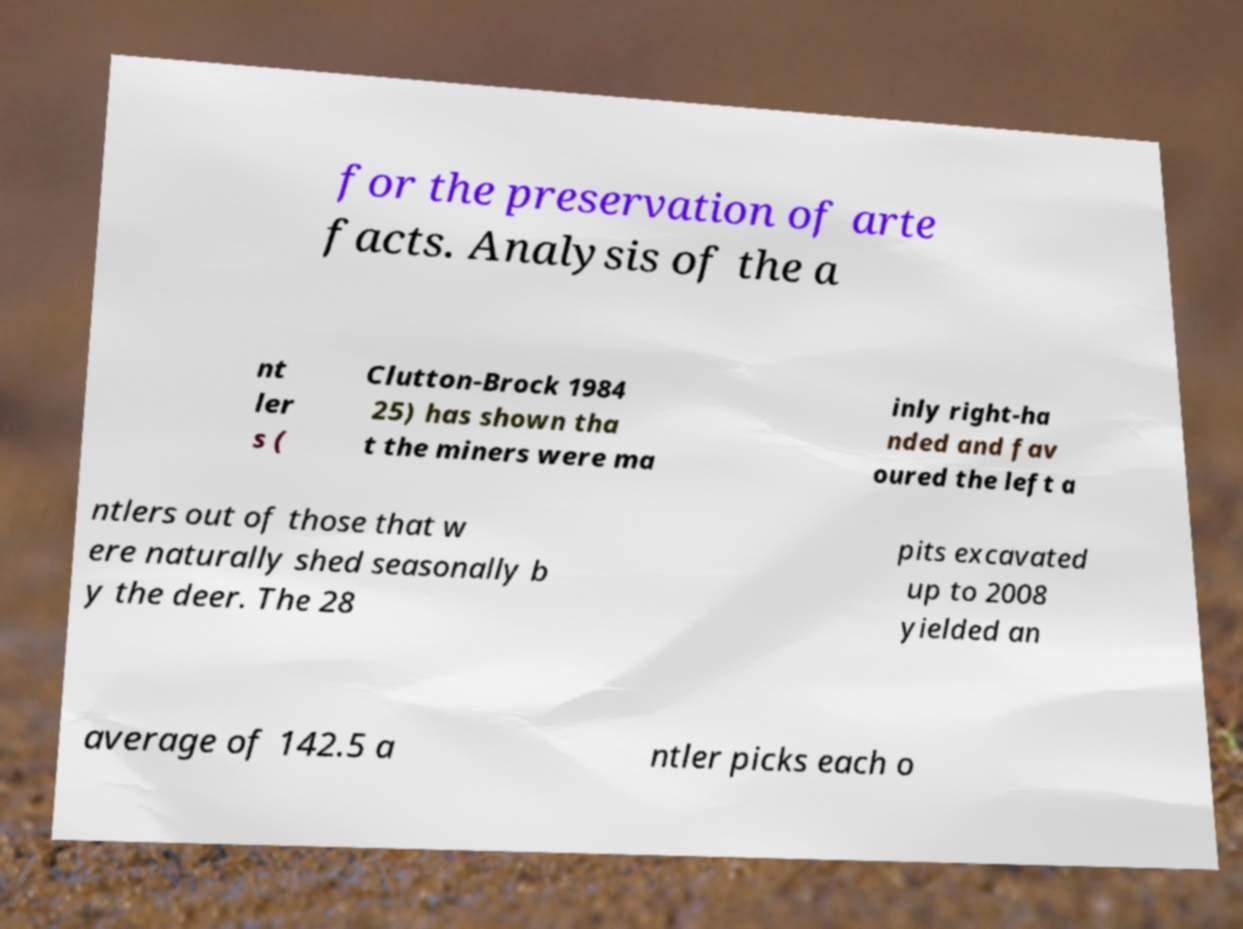Could you assist in decoding the text presented in this image and type it out clearly? for the preservation of arte facts. Analysis of the a nt ler s ( Clutton-Brock 1984 25) has shown tha t the miners were ma inly right-ha nded and fav oured the left a ntlers out of those that w ere naturally shed seasonally b y the deer. The 28 pits excavated up to 2008 yielded an average of 142.5 a ntler picks each o 